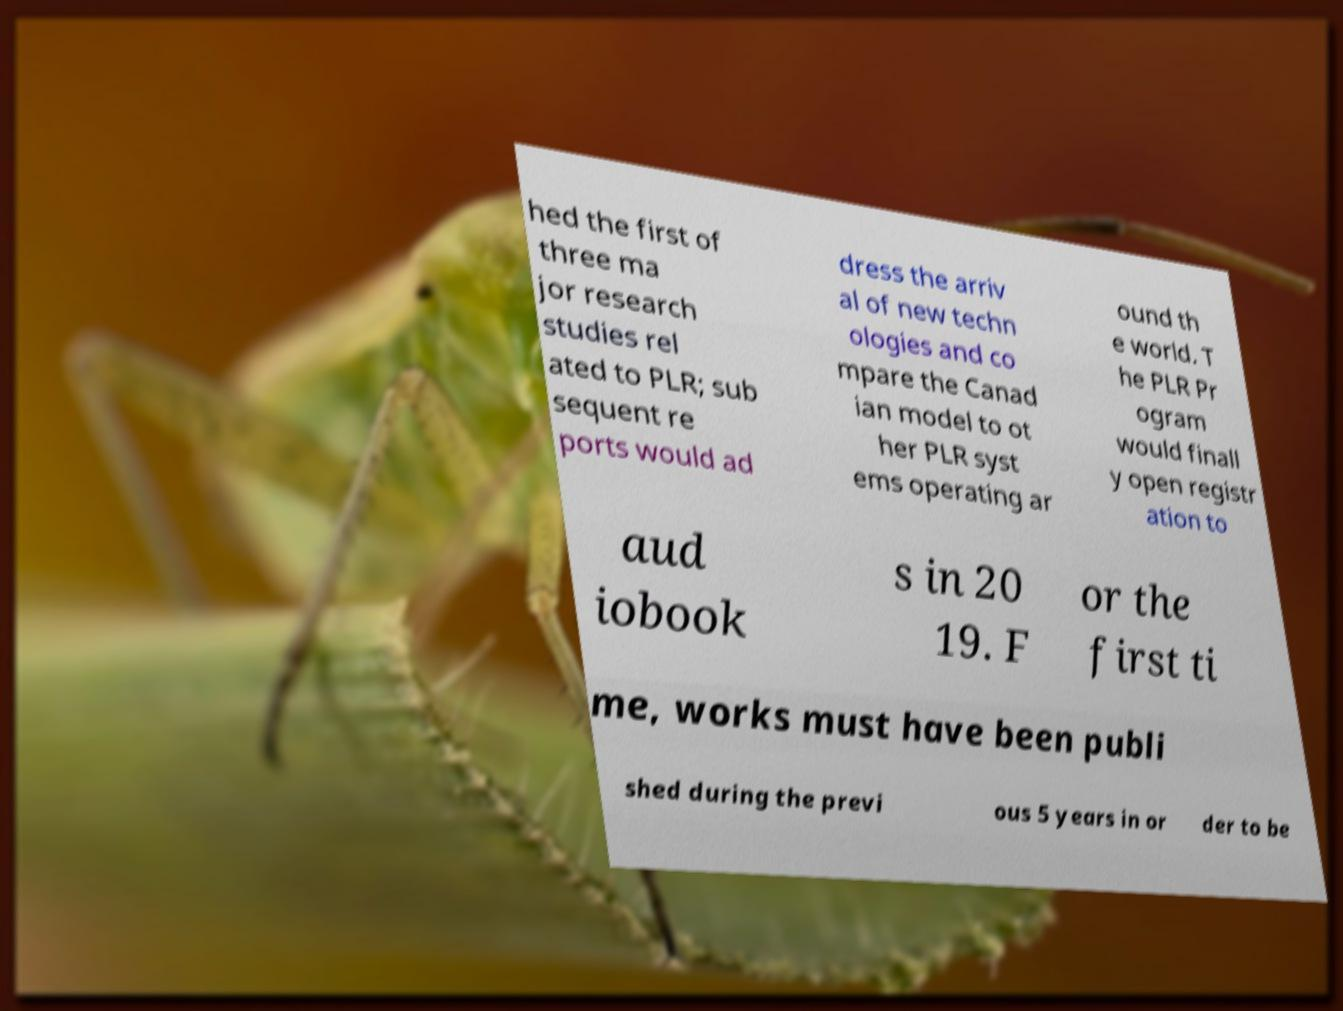Please identify and transcribe the text found in this image. hed the first of three ma jor research studies rel ated to PLR; sub sequent re ports would ad dress the arriv al of new techn ologies and co mpare the Canad ian model to ot her PLR syst ems operating ar ound th e world. T he PLR Pr ogram would finall y open registr ation to aud iobook s in 20 19. F or the first ti me, works must have been publi shed during the previ ous 5 years in or der to be 